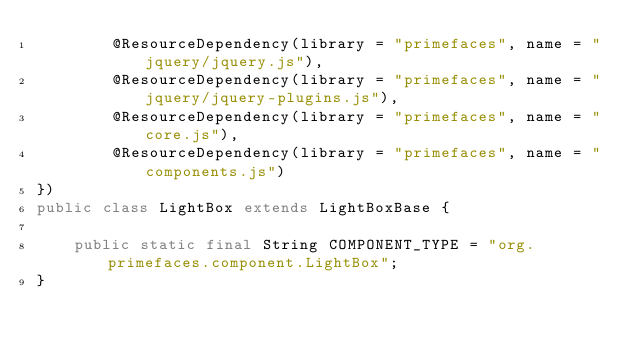<code> <loc_0><loc_0><loc_500><loc_500><_Java_>        @ResourceDependency(library = "primefaces", name = "jquery/jquery.js"),
        @ResourceDependency(library = "primefaces", name = "jquery/jquery-plugins.js"),
        @ResourceDependency(library = "primefaces", name = "core.js"),
        @ResourceDependency(library = "primefaces", name = "components.js")
})
public class LightBox extends LightBoxBase {

    public static final String COMPONENT_TYPE = "org.primefaces.component.LightBox";
}</code> 